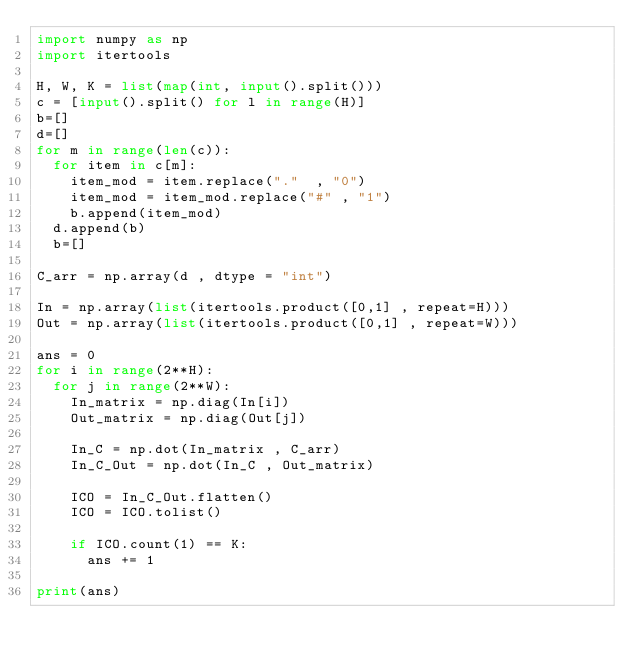<code> <loc_0><loc_0><loc_500><loc_500><_Python_>import numpy as np
import itertools

H, W, K = list(map(int, input().split())) 
c = [input().split() for l in range(H)]
b=[]
d=[]
for m in range(len(c)):
  for item in c[m]:
    item_mod = item.replace("."  , "0")
    item_mod = item_mod.replace("#" , "1")
    b.append(item_mod)
  d.append(b)
  b=[]

C_arr = np.array(d , dtype = "int")

In = np.array(list(itertools.product([0,1] , repeat=H)))
Out = np.array(list(itertools.product([0,1] , repeat=W)))

ans = 0
for i in range(2**H):
  for j in range(2**W):
    In_matrix = np.diag(In[i])
    Out_matrix = np.diag(Out[j])

    In_C = np.dot(In_matrix , C_arr)
    In_C_Out = np.dot(In_C , Out_matrix)

    ICO = In_C_Out.flatten()
    ICO = ICO.tolist()

    if ICO.count(1) == K:
      ans += 1

print(ans)</code> 